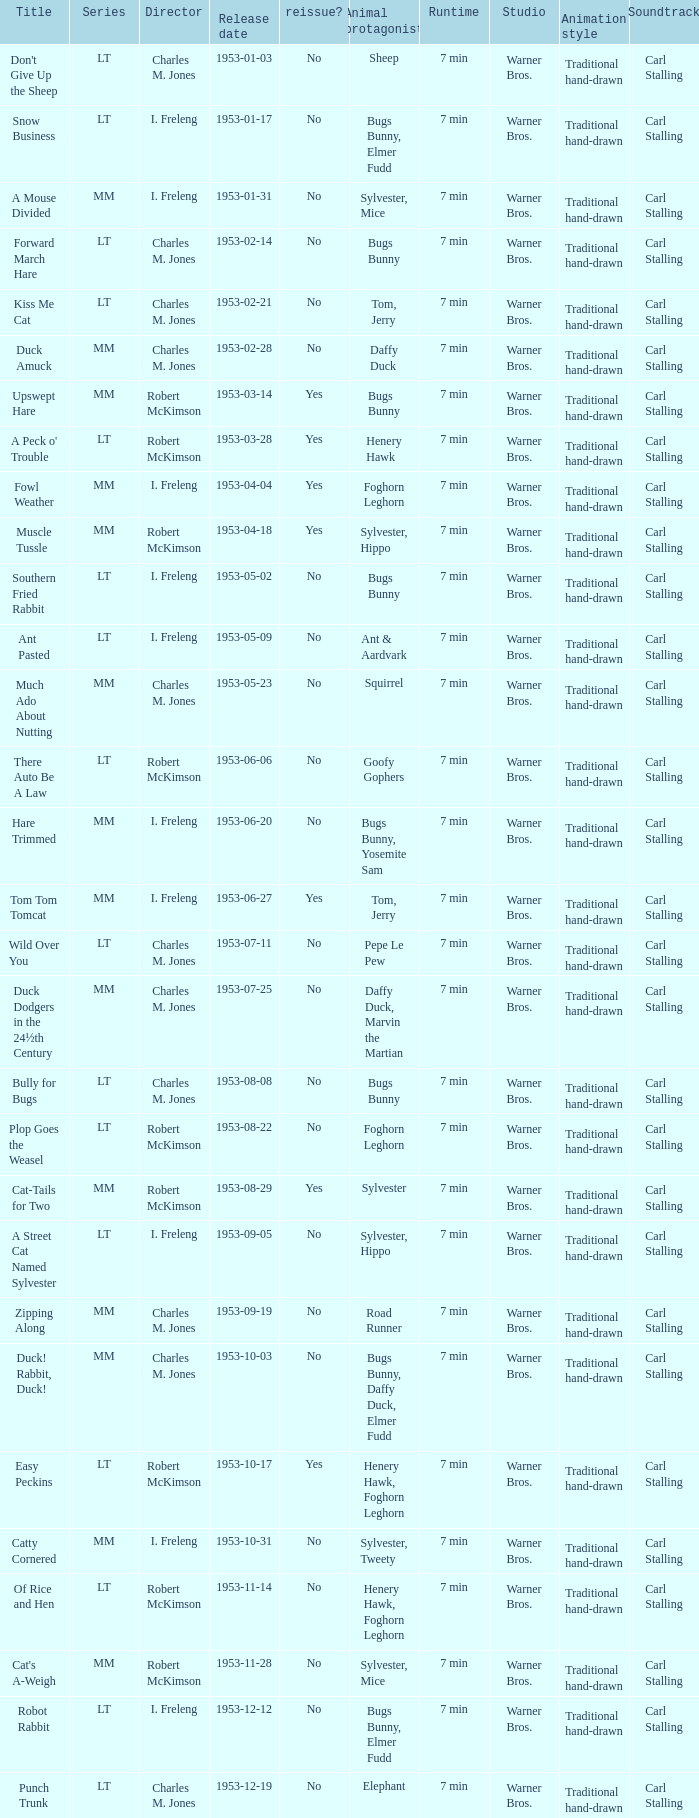What's the title for the release date of 1953-01-31 in the MM series, no reissue, and a director of I. Freleng? A Mouse Divided. 